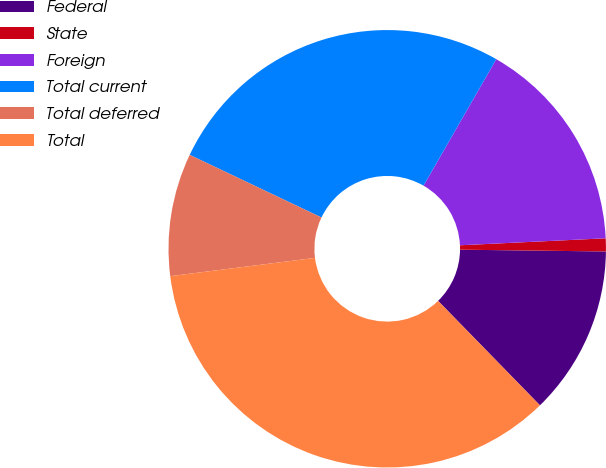Convert chart to OTSL. <chart><loc_0><loc_0><loc_500><loc_500><pie_chart><fcel>Federal<fcel>State<fcel>Foreign<fcel>Total current<fcel>Total deferred<fcel>Total<nl><fcel>12.5%<fcel>0.96%<fcel>15.93%<fcel>26.24%<fcel>9.06%<fcel>35.3%<nl></chart> 